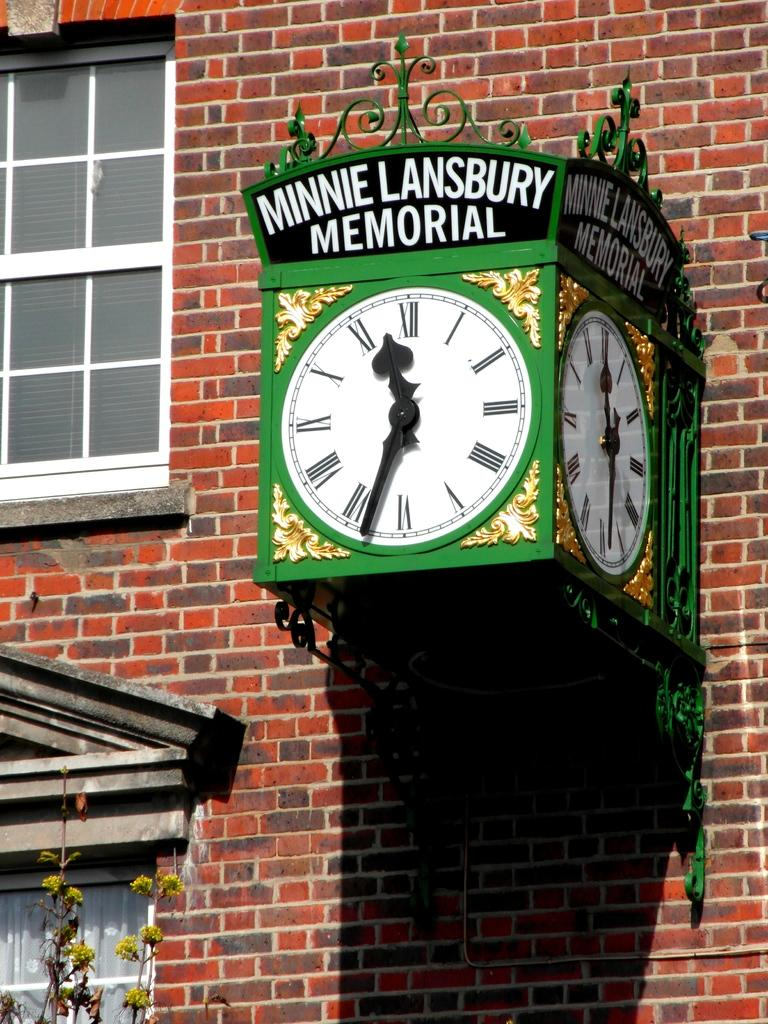<image>
Describe the image concisely. a clock outside of a building that is labeled 'minnie lansbury memorial' 